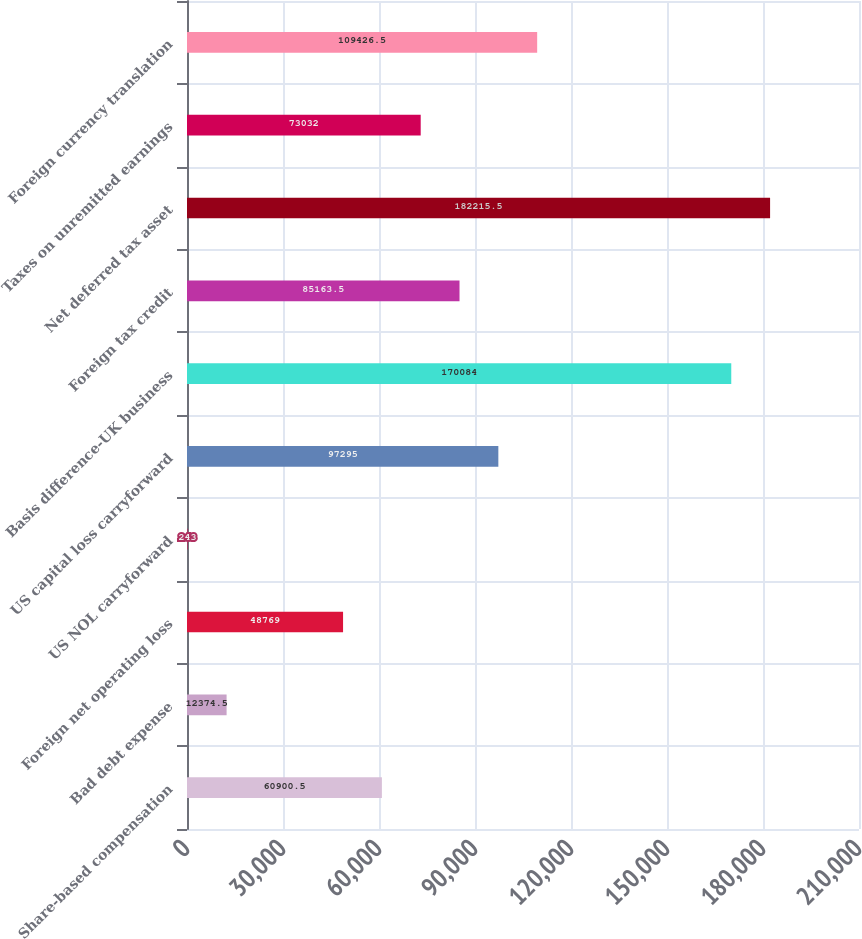Convert chart. <chart><loc_0><loc_0><loc_500><loc_500><bar_chart><fcel>Share-based compensation<fcel>Bad debt expense<fcel>Foreign net operating loss<fcel>US NOL carryforward<fcel>US capital loss carryforward<fcel>Basis difference-UK business<fcel>Foreign tax credit<fcel>Net deferred tax asset<fcel>Taxes on unremitted earnings<fcel>Foreign currency translation<nl><fcel>60900.5<fcel>12374.5<fcel>48769<fcel>243<fcel>97295<fcel>170084<fcel>85163.5<fcel>182216<fcel>73032<fcel>109426<nl></chart> 